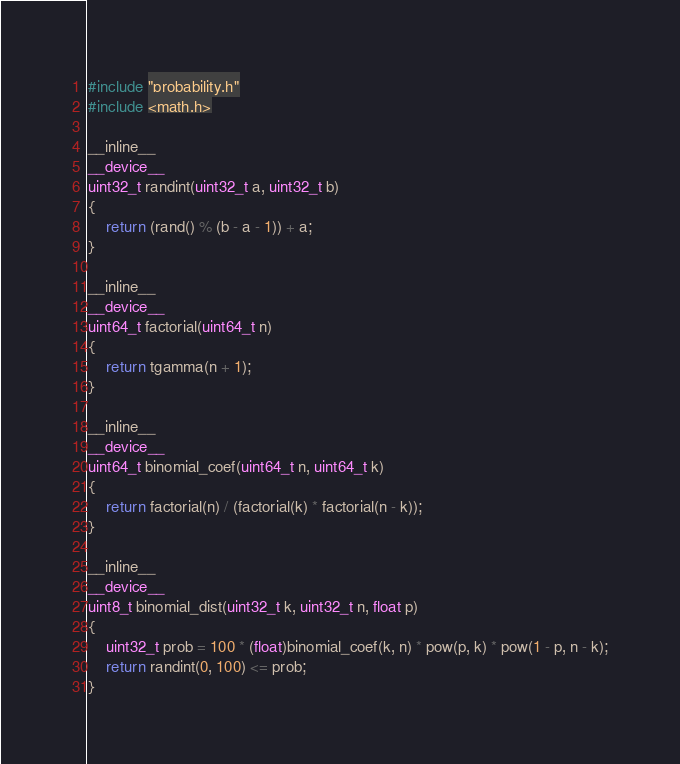Convert code to text. <code><loc_0><loc_0><loc_500><loc_500><_Cuda_>#include "probability.h"
#include <math.h>

__inline__
__device__
uint32_t randint(uint32_t a, uint32_t b)
{
	return (rand() % (b - a - 1)) + a;
}

__inline__
__device__
uint64_t factorial(uint64_t n)
{
	return tgamma(n + 1);
}

__inline__
__device__
uint64_t binomial_coef(uint64_t n, uint64_t k)
{
	return factorial(n) / (factorial(k) * factorial(n - k));
}

__inline__
__device__
uint8_t binomial_dist(uint32_t k, uint32_t n, float p)
{
	uint32_t prob = 100 * (float)binomial_coef(k, n) * pow(p, k) * pow(1 - p, n - k);
	return randint(0, 100) <= prob;		
}
</code> 